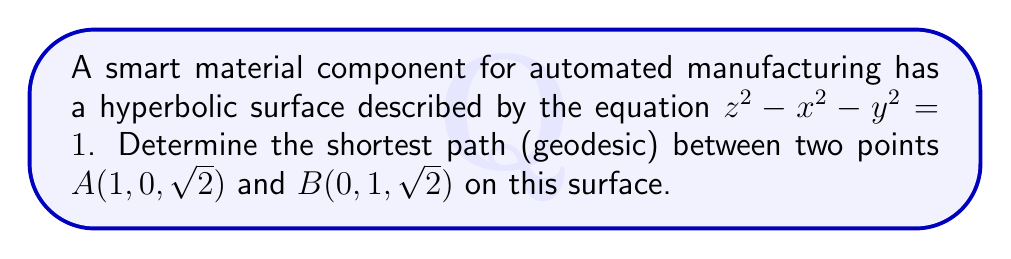Teach me how to tackle this problem. To find the shortest path between two points on a hyperbolic surface, we need to follow these steps:

1) First, we recognize that the given surface is a hyperboloid of two sheets. The shortest path between two points on such a surface is a hyperbolic geodesic.

2) For a hyperboloid of two sheets described by $z^2 - x^2 - y^2 = 1$, the geodesics are the intersections of this surface with planes passing through the origin.

3) We need to find the equation of the plane that passes through the origin and both points A and B.

4) To do this, we can use the general equation of a plane: $ax + by + cz + d = 0$
   Since it passes through the origin, $d = 0$
   So our plane equation is $ax + by + cz = 0$

5) Substituting the coordinates of A and B:
   For A: $a(1) + b(0) + c(\sqrt{2}) = 0$
   For B: $a(0) + b(1) + c(\sqrt{2}) = 0$

6) From these equations, we can deduce that $a = b = -c/\sqrt{2}$

7) Therefore, the equation of our plane is:
   $x + y - \sqrt{2}z = 0$

8) The shortest path (geodesic) is the intersection of this plane with our hyperboloid surface. It can be parametrized as:

   $$\begin{cases}
   x(t) = \frac{\sqrt{2}}{2} \sinh(t) \\
   y(t) = \frac{\sqrt{2}}{2} \sinh(t) \\
   z(t) = \cosh(t)
   \end{cases}$$

   where $t$ is a parameter.

9) The length of this geodesic between A and B can be calculated using the arc length formula, but that's beyond the scope of this question.
Answer: The shortest path is the intersection of the plane $x + y - \sqrt{2}z = 0$ with the hyperboloid $z^2 - x^2 - y^2 = 1$. 